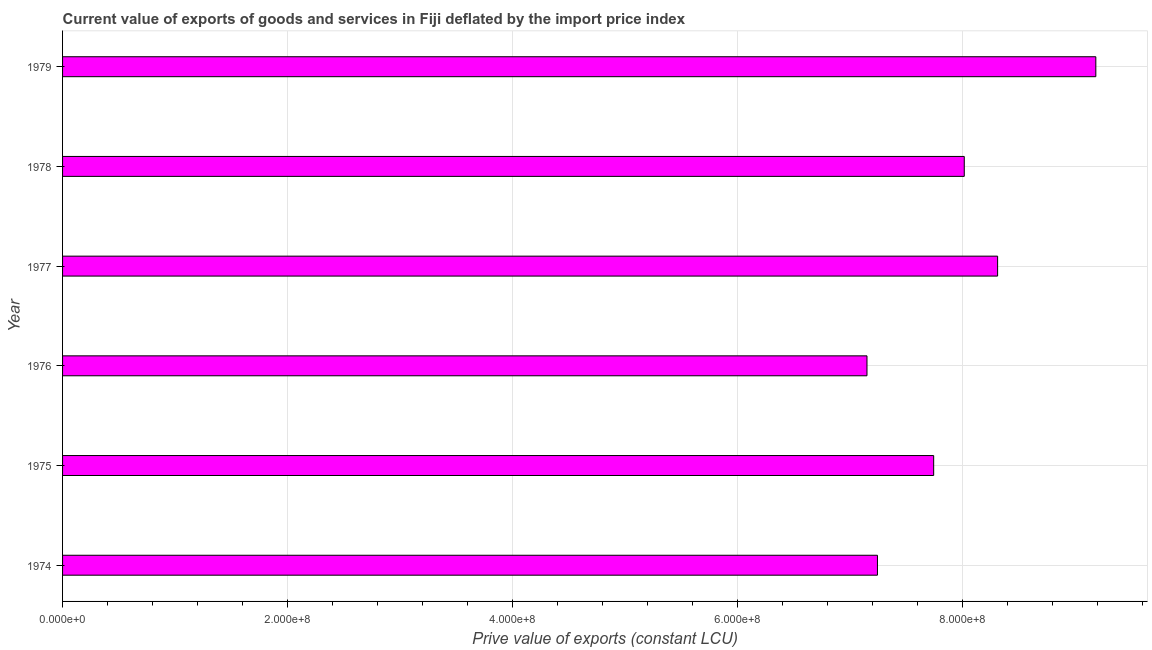Does the graph contain grids?
Offer a terse response. Yes. What is the title of the graph?
Your answer should be compact. Current value of exports of goods and services in Fiji deflated by the import price index. What is the label or title of the X-axis?
Offer a very short reply. Prive value of exports (constant LCU). What is the label or title of the Y-axis?
Give a very brief answer. Year. What is the price value of exports in 1974?
Offer a terse response. 7.24e+08. Across all years, what is the maximum price value of exports?
Provide a succinct answer. 9.18e+08. Across all years, what is the minimum price value of exports?
Offer a very short reply. 7.15e+08. In which year was the price value of exports maximum?
Offer a very short reply. 1979. In which year was the price value of exports minimum?
Offer a terse response. 1976. What is the sum of the price value of exports?
Your response must be concise. 4.76e+09. What is the difference between the price value of exports in 1974 and 1976?
Offer a very short reply. 9.29e+06. What is the average price value of exports per year?
Offer a terse response. 7.94e+08. What is the median price value of exports?
Provide a short and direct response. 7.88e+08. In how many years, is the price value of exports greater than 320000000 LCU?
Give a very brief answer. 6. What is the ratio of the price value of exports in 1976 to that in 1978?
Offer a very short reply. 0.89. What is the difference between the highest and the second highest price value of exports?
Your answer should be compact. 8.73e+07. Is the sum of the price value of exports in 1976 and 1979 greater than the maximum price value of exports across all years?
Make the answer very short. Yes. What is the difference between the highest and the lowest price value of exports?
Provide a succinct answer. 2.03e+08. In how many years, is the price value of exports greater than the average price value of exports taken over all years?
Your answer should be compact. 3. How many bars are there?
Ensure brevity in your answer.  6. Are all the bars in the graph horizontal?
Provide a succinct answer. Yes. What is the difference between two consecutive major ticks on the X-axis?
Your answer should be very brief. 2.00e+08. Are the values on the major ticks of X-axis written in scientific E-notation?
Your answer should be very brief. Yes. What is the Prive value of exports (constant LCU) of 1974?
Keep it short and to the point. 7.24e+08. What is the Prive value of exports (constant LCU) in 1975?
Provide a short and direct response. 7.74e+08. What is the Prive value of exports (constant LCU) in 1976?
Your answer should be compact. 7.15e+08. What is the Prive value of exports (constant LCU) in 1977?
Your response must be concise. 8.31e+08. What is the Prive value of exports (constant LCU) in 1978?
Ensure brevity in your answer.  8.01e+08. What is the Prive value of exports (constant LCU) in 1979?
Make the answer very short. 9.18e+08. What is the difference between the Prive value of exports (constant LCU) in 1974 and 1975?
Provide a succinct answer. -5.00e+07. What is the difference between the Prive value of exports (constant LCU) in 1974 and 1976?
Your response must be concise. 9.29e+06. What is the difference between the Prive value of exports (constant LCU) in 1974 and 1977?
Your answer should be compact. -1.07e+08. What is the difference between the Prive value of exports (constant LCU) in 1974 and 1978?
Your response must be concise. -7.72e+07. What is the difference between the Prive value of exports (constant LCU) in 1974 and 1979?
Offer a very short reply. -1.94e+08. What is the difference between the Prive value of exports (constant LCU) in 1975 and 1976?
Offer a very short reply. 5.93e+07. What is the difference between the Prive value of exports (constant LCU) in 1975 and 1977?
Keep it short and to the point. -5.68e+07. What is the difference between the Prive value of exports (constant LCU) in 1975 and 1978?
Keep it short and to the point. -2.72e+07. What is the difference between the Prive value of exports (constant LCU) in 1975 and 1979?
Provide a succinct answer. -1.44e+08. What is the difference between the Prive value of exports (constant LCU) in 1976 and 1977?
Offer a terse response. -1.16e+08. What is the difference between the Prive value of exports (constant LCU) in 1976 and 1978?
Offer a terse response. -8.64e+07. What is the difference between the Prive value of exports (constant LCU) in 1976 and 1979?
Offer a terse response. -2.03e+08. What is the difference between the Prive value of exports (constant LCU) in 1977 and 1978?
Your answer should be very brief. 2.96e+07. What is the difference between the Prive value of exports (constant LCU) in 1977 and 1979?
Ensure brevity in your answer.  -8.73e+07. What is the difference between the Prive value of exports (constant LCU) in 1978 and 1979?
Your answer should be compact. -1.17e+08. What is the ratio of the Prive value of exports (constant LCU) in 1974 to that in 1975?
Make the answer very short. 0.94. What is the ratio of the Prive value of exports (constant LCU) in 1974 to that in 1977?
Your response must be concise. 0.87. What is the ratio of the Prive value of exports (constant LCU) in 1974 to that in 1978?
Your answer should be very brief. 0.9. What is the ratio of the Prive value of exports (constant LCU) in 1974 to that in 1979?
Offer a terse response. 0.79. What is the ratio of the Prive value of exports (constant LCU) in 1975 to that in 1976?
Provide a succinct answer. 1.08. What is the ratio of the Prive value of exports (constant LCU) in 1975 to that in 1977?
Provide a short and direct response. 0.93. What is the ratio of the Prive value of exports (constant LCU) in 1975 to that in 1979?
Offer a terse response. 0.84. What is the ratio of the Prive value of exports (constant LCU) in 1976 to that in 1977?
Give a very brief answer. 0.86. What is the ratio of the Prive value of exports (constant LCU) in 1976 to that in 1978?
Keep it short and to the point. 0.89. What is the ratio of the Prive value of exports (constant LCU) in 1976 to that in 1979?
Keep it short and to the point. 0.78. What is the ratio of the Prive value of exports (constant LCU) in 1977 to that in 1979?
Offer a terse response. 0.91. What is the ratio of the Prive value of exports (constant LCU) in 1978 to that in 1979?
Provide a short and direct response. 0.87. 